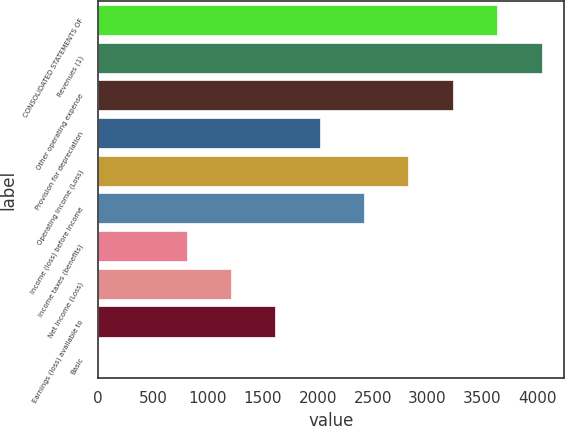Convert chart. <chart><loc_0><loc_0><loc_500><loc_500><bar_chart><fcel>CONSOLIDATED STATEMENTS OF<fcel>Revenues (1)<fcel>Other operating expense<fcel>Provision for depreciation<fcel>Operating Income (Loss)<fcel>Income (loss) before income<fcel>Income taxes (benefits)<fcel>Net Income (Loss)<fcel>Earnings (loss) available to<fcel>Basic<nl><fcel>3633.33<fcel>4037<fcel>3229.68<fcel>2018.73<fcel>2826.03<fcel>2422.38<fcel>807.78<fcel>1211.43<fcel>1615.08<fcel>0.48<nl></chart> 